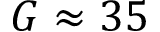Convert formula to latex. <formula><loc_0><loc_0><loc_500><loc_500>G \approx 3 5</formula> 